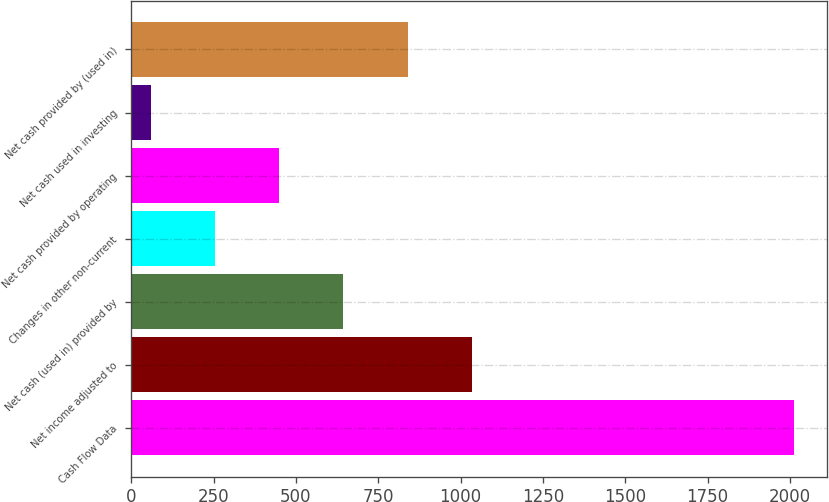Convert chart to OTSL. <chart><loc_0><loc_0><loc_500><loc_500><bar_chart><fcel>Cash Flow Data<fcel>Net income adjusted to<fcel>Net cash (used in) provided by<fcel>Changes in other non-current<fcel>Net cash provided by operating<fcel>Net cash used in investing<fcel>Net cash provided by (used in)<nl><fcel>2011<fcel>1034.9<fcel>644.46<fcel>254.02<fcel>449.24<fcel>58.8<fcel>839.68<nl></chart> 